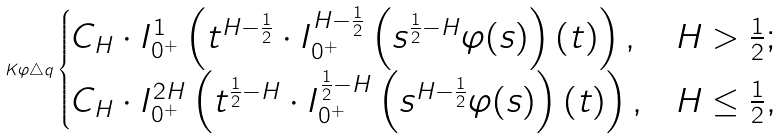Convert formula to latex. <formula><loc_0><loc_0><loc_500><loc_500>K \varphi \triangle q \begin{cases} C _ { H } \cdot I _ { 0 ^ { + } } ^ { 1 } \left ( t ^ { H - \frac { 1 } { 2 } } \cdot I _ { 0 ^ { + } } ^ { H - \frac { 1 } { 2 } } \left ( s ^ { \frac { 1 } { 2 } - H } \varphi ( s ) \right ) ( t ) \right ) , & H > \frac { 1 } { 2 } ; \\ C _ { H } \cdot I _ { 0 ^ { + } } ^ { 2 H } \left ( t ^ { \frac { 1 } { 2 } - H } \cdot I _ { 0 ^ { + } } ^ { \frac { 1 } { 2 } - H } \left ( s ^ { H - \frac { 1 } { 2 } } \varphi ( s ) \right ) ( t ) \right ) , & H \leq \frac { 1 } { 2 } , \end{cases}</formula> 